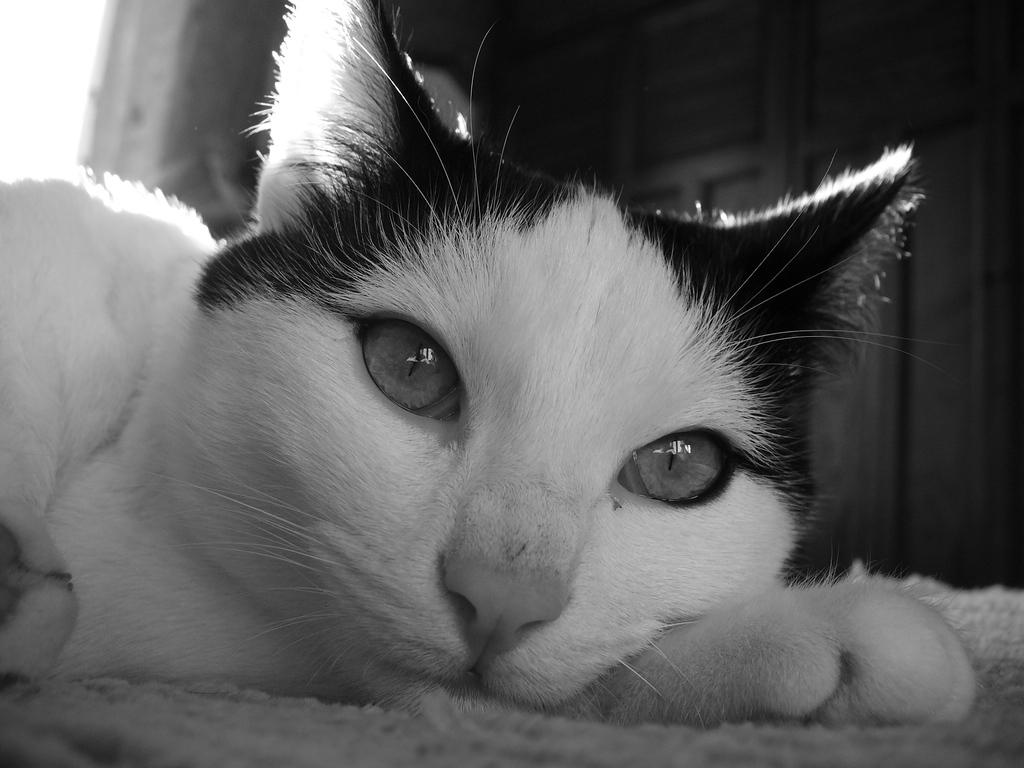What type of animal is in the picture? There is a cat in the picture. Can you describe the color of the cat? The cat is white and brown in color. What is the cat doing in the picture? The cat is resting on the ground. What type of plant is growing on the cat's face in the image? There is no plant growing on the cat's face in the image, as the cat does not have a face. 